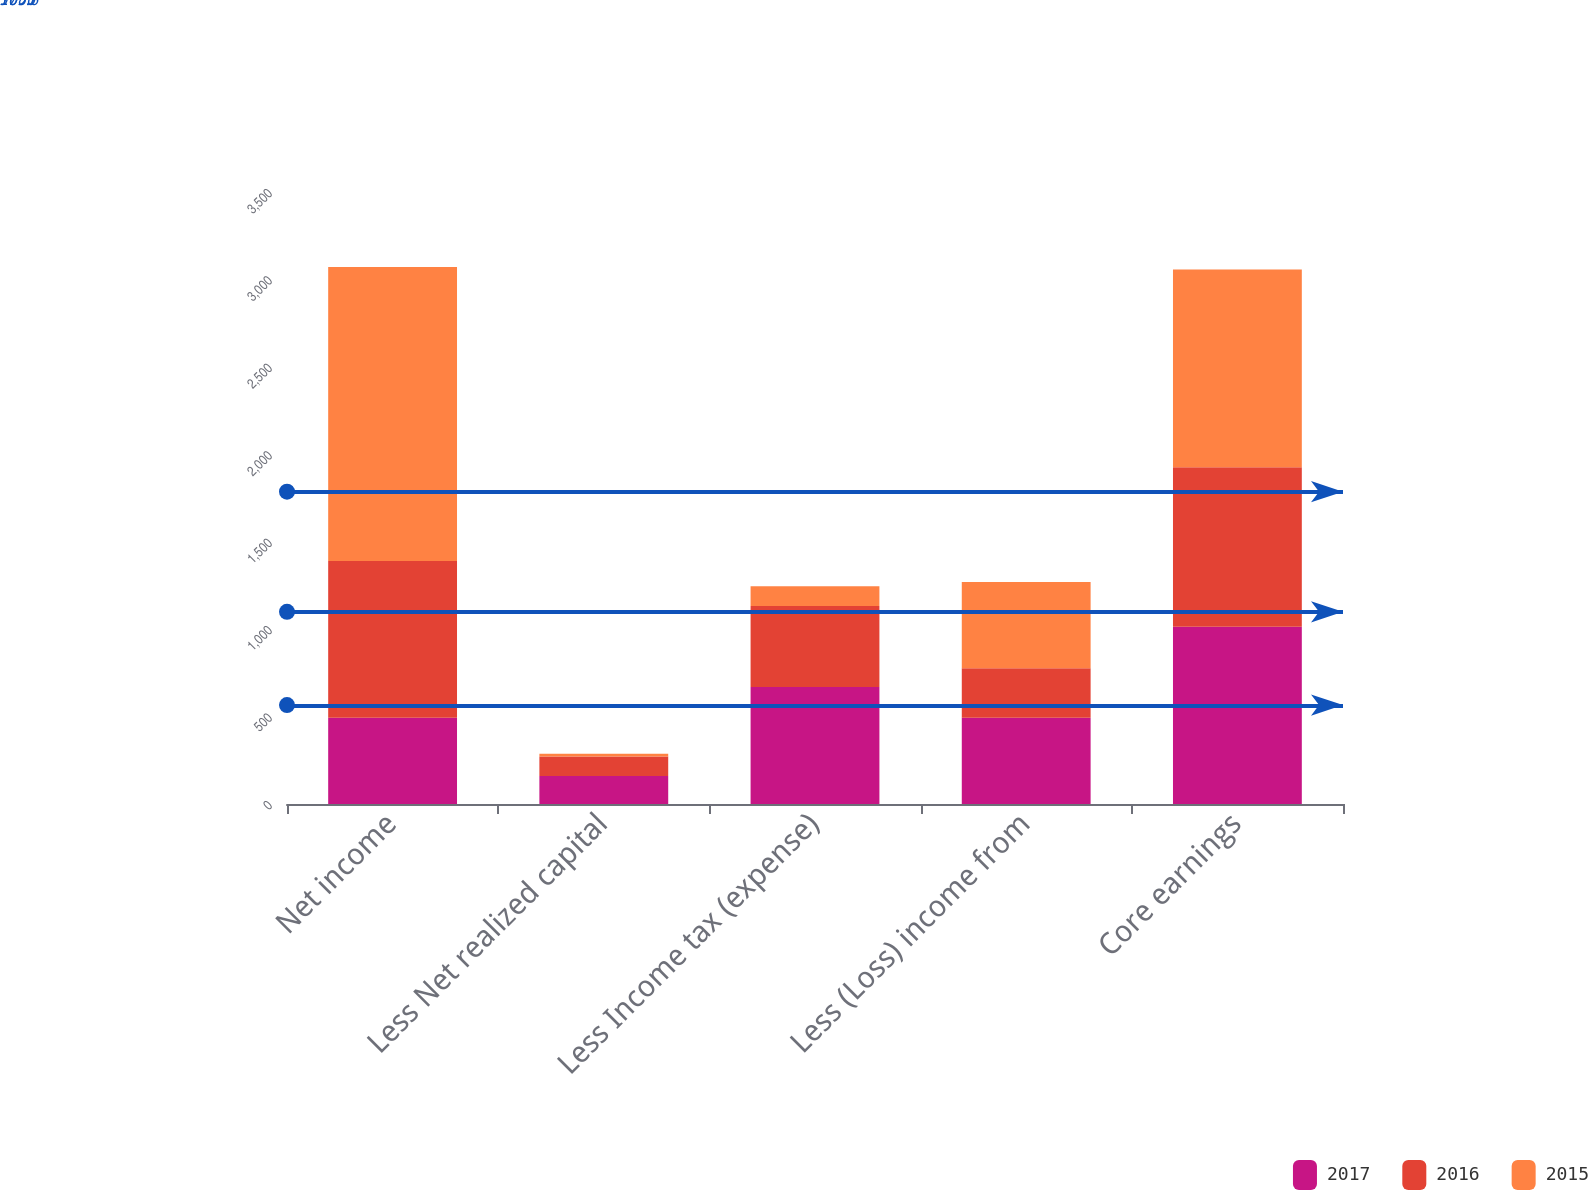Convert chart to OTSL. <chart><loc_0><loc_0><loc_500><loc_500><stacked_bar_chart><ecel><fcel>Net income<fcel>Less Net realized capital<fcel>Less Income tax (expense)<fcel>Less (Loss) income from<fcel>Core earnings<nl><fcel>2017<fcel>493<fcel>160<fcel>669<fcel>493<fcel>1014<nl><fcel>2016<fcel>896<fcel>112<fcel>463<fcel>283<fcel>912<nl><fcel>2015<fcel>1682<fcel>15<fcel>114<fcel>493<fcel>1131<nl></chart> 